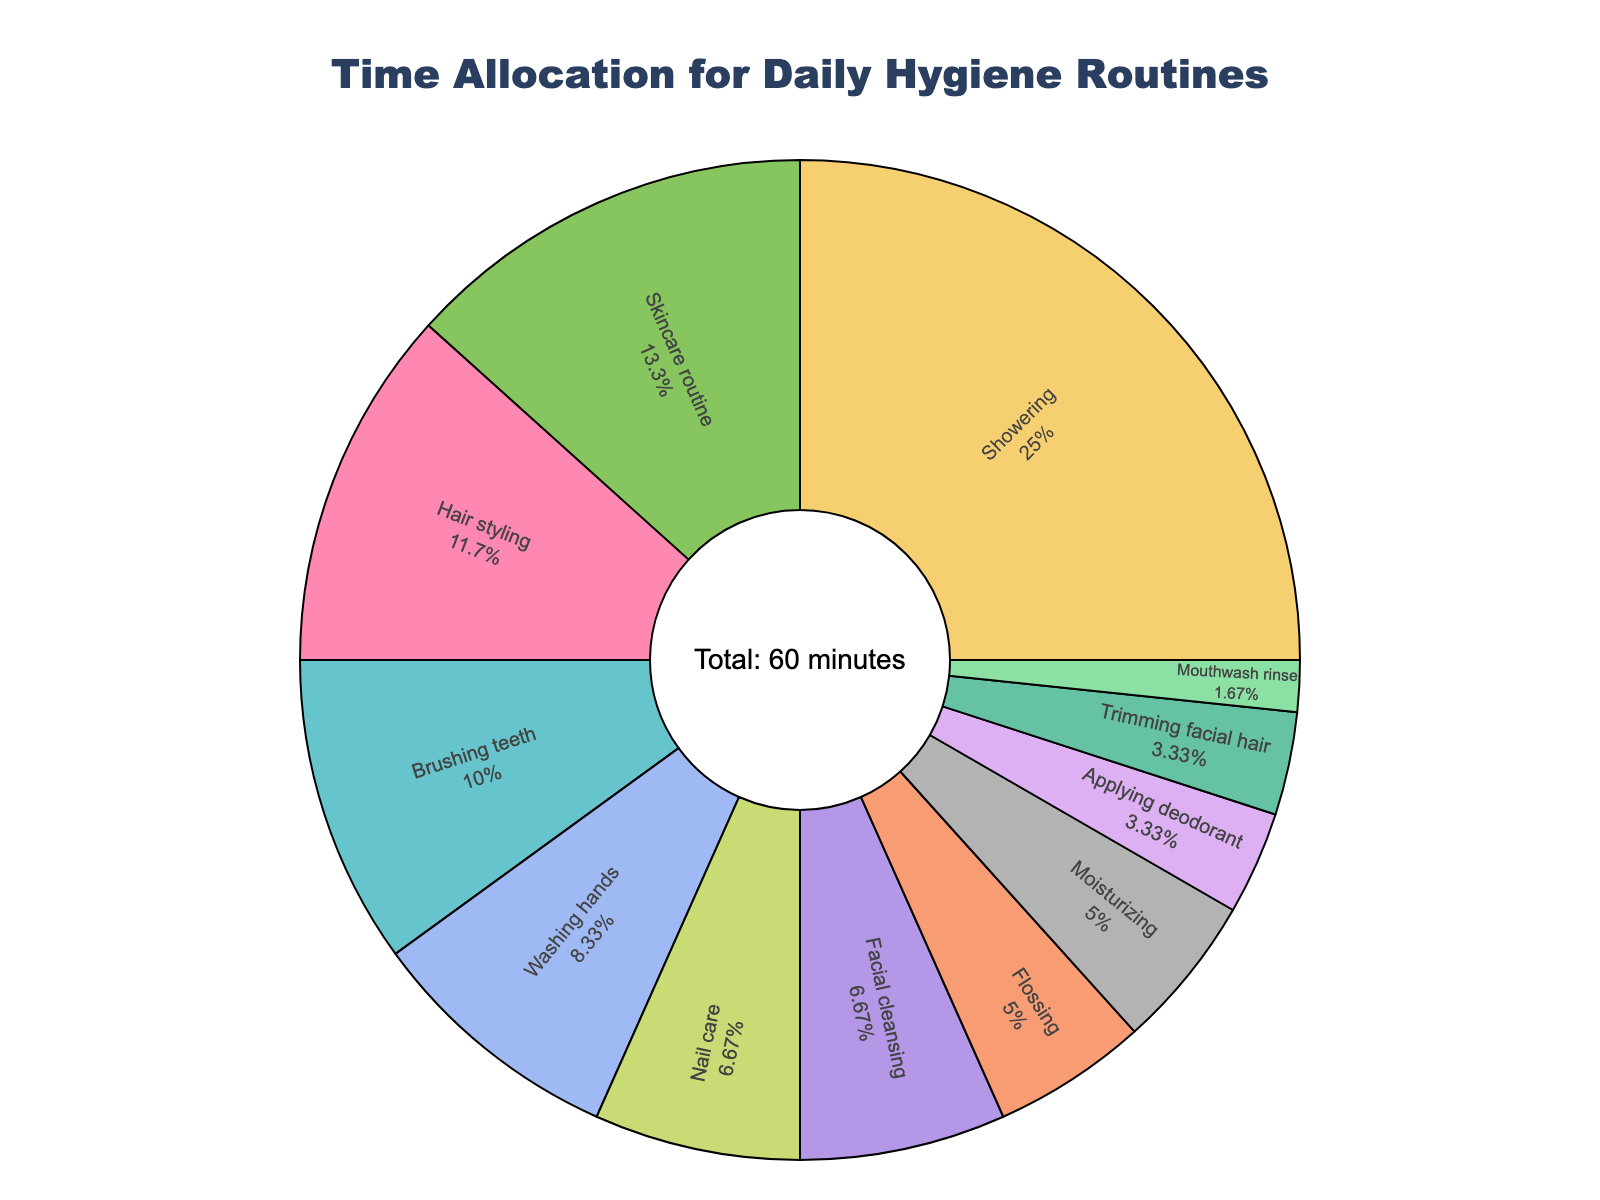Which activity takes up the most time? The activity which has the largest pie slice represents the one taking up the most time. By observing the figure, "Showering" takes up the largest portion.
Answer: Showering Which activity takes up the least time? The smallest slice of the pie chart will indicate the activity that takes up the least time. Here, "Mouthwash rinse" has the smallest portion.
Answer: Mouthwash rinse What is the total time spent on facial care activities (skincare routine, facial cleansing, moisturizing)? To find the total time, add up the minutes spent on "skincare routine", "facial cleansing", and "moisturizing". That’s 8 + 4 + 3 minutes.
Answer: 15 minutes How much more time is spent showering compared to brushing teeth? Subtract the time spent on "Brushing teeth" from the time spent on "Showering". That’s 15 - 6 minutes.
Answer: 9 minutes Which activity has a higher percentage of time allocation, hair styling or nail care? Compare the sizes of the corresponding pie slices. "Hair styling" has a larger slice than "Nail care".
Answer: Hair styling What is the overall time spent on oral care activities (brushing teeth, flossing, mouthwash rinse)? To get the total time for oral care activities, sum up the minutes for "Brushing teeth", "Flossing", and "Mouthwash rinse". That’s 6 + 3 + 1 minutes.
Answer: 10 minutes How much more time is spent on skincare routine compared to washing hands? Subtract the time for "Washing hands" from the time for "Skincare routine". That’s 8 - 5 minutes.
Answer: 3 minutes What is the ratio of time spent showering to the time spent applying deodorant? Divide the time spent on "Showering" by the time spent on "Applying deodorant". That’s 15 / 2.
Answer: 7.5 What percentage of the total time is spent on hair care activities (hair styling and applying deodorant)? First, sum the minutes for "Hair styling" and "Applying deodorant", which is 7 + 2 = 9 minutes. Then, calculate the percentage of total time by dividing this by the total minutes (60 minutes), and then multiplying the result by 100.
Answer: 15% Comparing facial care and oral care activities, which group has a higher total time allocation? Calculate the total time for facial care (8 + 4 + 3 = 15 minutes) and oral care (6 + 3 + 1 = 10 minutes), then compare.
Answer: Facial care 